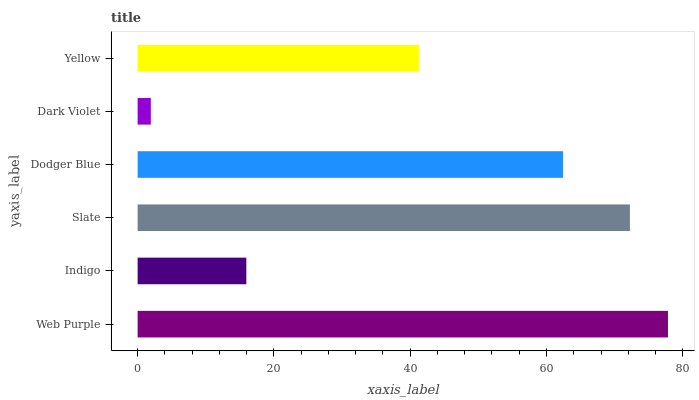Is Dark Violet the minimum?
Answer yes or no. Yes. Is Web Purple the maximum?
Answer yes or no. Yes. Is Indigo the minimum?
Answer yes or no. No. Is Indigo the maximum?
Answer yes or no. No. Is Web Purple greater than Indigo?
Answer yes or no. Yes. Is Indigo less than Web Purple?
Answer yes or no. Yes. Is Indigo greater than Web Purple?
Answer yes or no. No. Is Web Purple less than Indigo?
Answer yes or no. No. Is Dodger Blue the high median?
Answer yes or no. Yes. Is Yellow the low median?
Answer yes or no. Yes. Is Slate the high median?
Answer yes or no. No. Is Web Purple the low median?
Answer yes or no. No. 